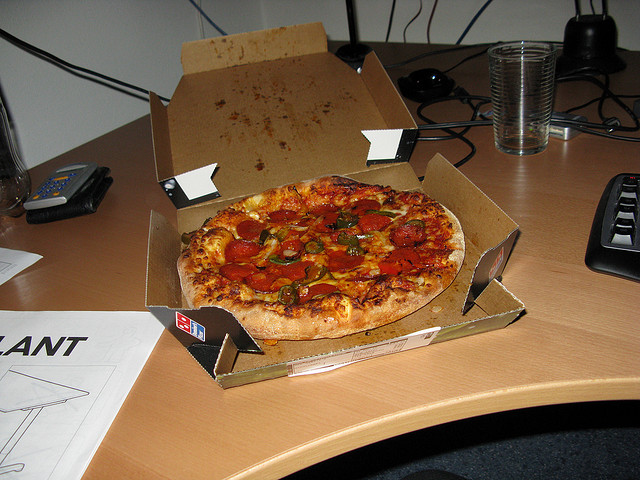Can you suggest what the person might have been working on, based on the items on the desk? Based on the items observed on the desk, it appears the person might have been engaged in a variety of activities. The presence of a calculator and wallet suggests some form of financial management or budgeting. The visible parts of a computer monitor and keyboard indicate typical office-related tasks such as emailing, document creation, or data entry. Additionally, the papers and drawings could imply that the person was involved in artistic design work or jotting down creative ideas. Would these items suggest the person is organizing a big project? Yes, the mix of financial tools like a calculator and wallet along with creative materials like drawings and scattered papers does suggest that the person could be organizing a substantial project. This project could involve budget planning and creative design, possibly indicating a role that combines administrative and creative responsibilities. 